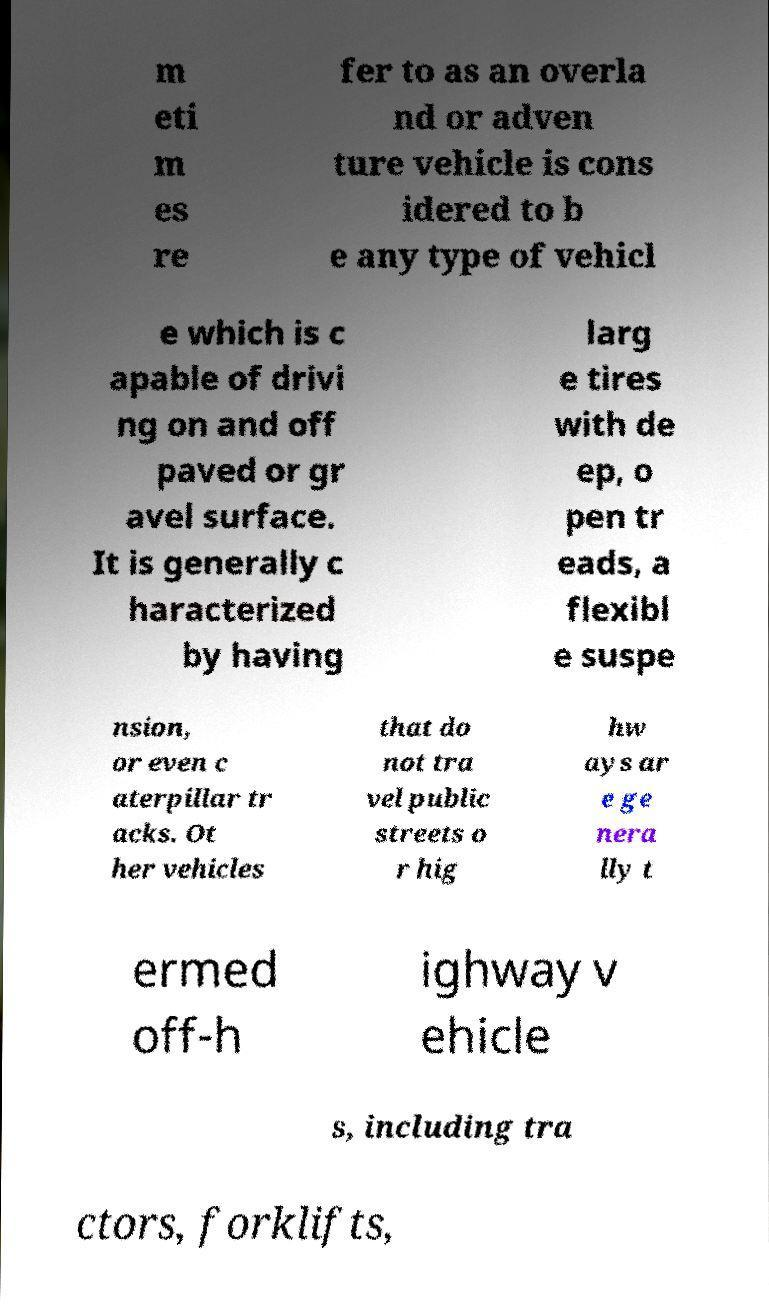Please read and relay the text visible in this image. What does it say? m eti m es re fer to as an overla nd or adven ture vehicle is cons idered to b e any type of vehicl e which is c apable of drivi ng on and off paved or gr avel surface. It is generally c haracterized by having larg e tires with de ep, o pen tr eads, a flexibl e suspe nsion, or even c aterpillar tr acks. Ot her vehicles that do not tra vel public streets o r hig hw ays ar e ge nera lly t ermed off-h ighway v ehicle s, including tra ctors, forklifts, 